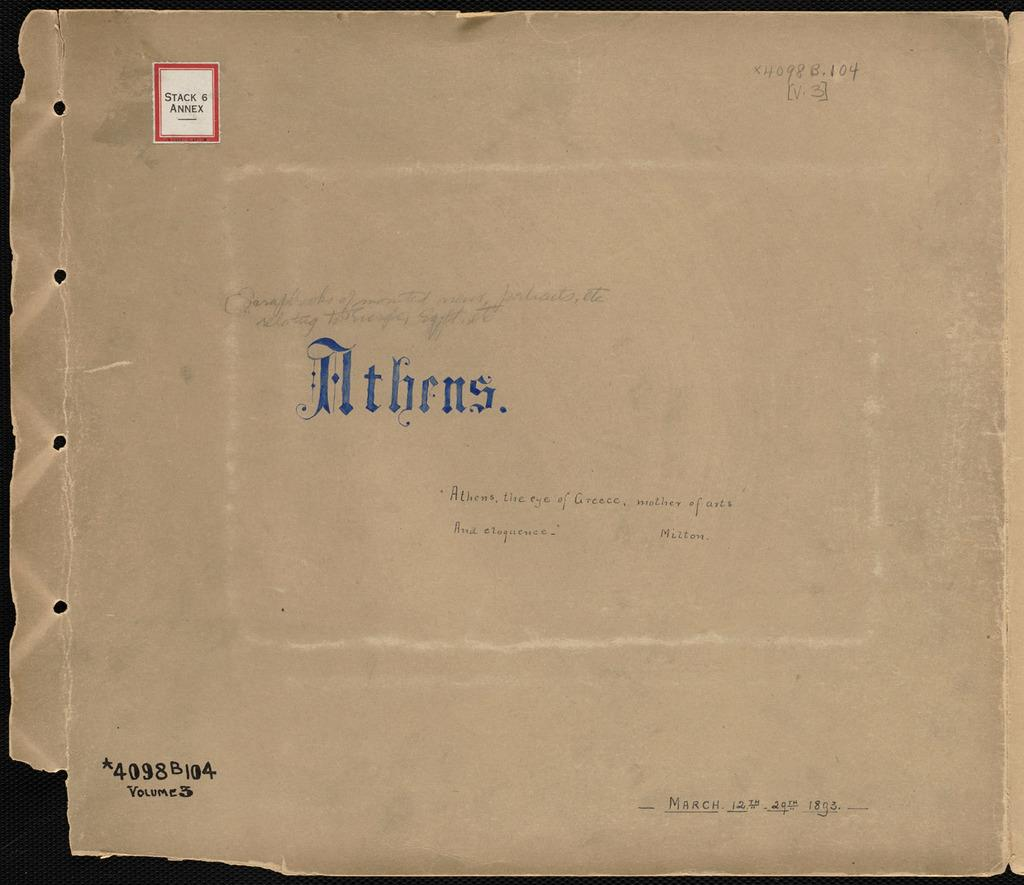<image>
Give a short and clear explanation of the subsequent image. The envelop has a stamp in the upper left that reads Stack 6 Annex. 